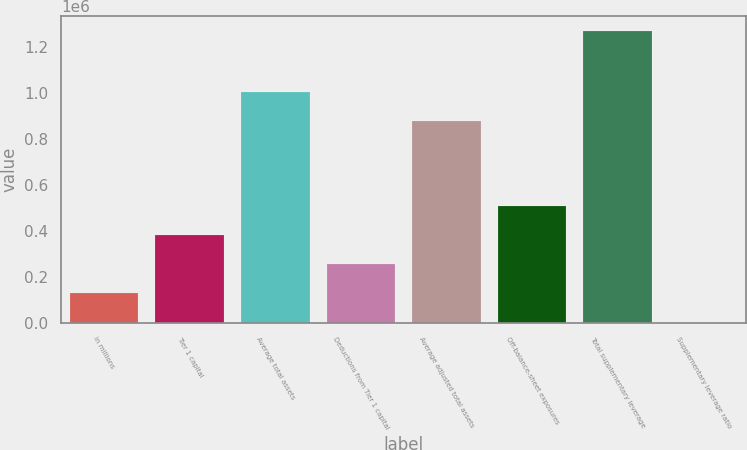<chart> <loc_0><loc_0><loc_500><loc_500><bar_chart><fcel>in millions<fcel>Tier 1 capital<fcel>Average total assets<fcel>Deductions from Tier 1 capital<fcel>Average adjusted total assets<fcel>Off-balance-sheet exposures<fcel>Total supplementary leverage<fcel>Supplementary leverage ratio<nl><fcel>127023<fcel>381056<fcel>1.00563e+06<fcel>254040<fcel>878618<fcel>508073<fcel>1.27017e+06<fcel>6.4<nl></chart> 